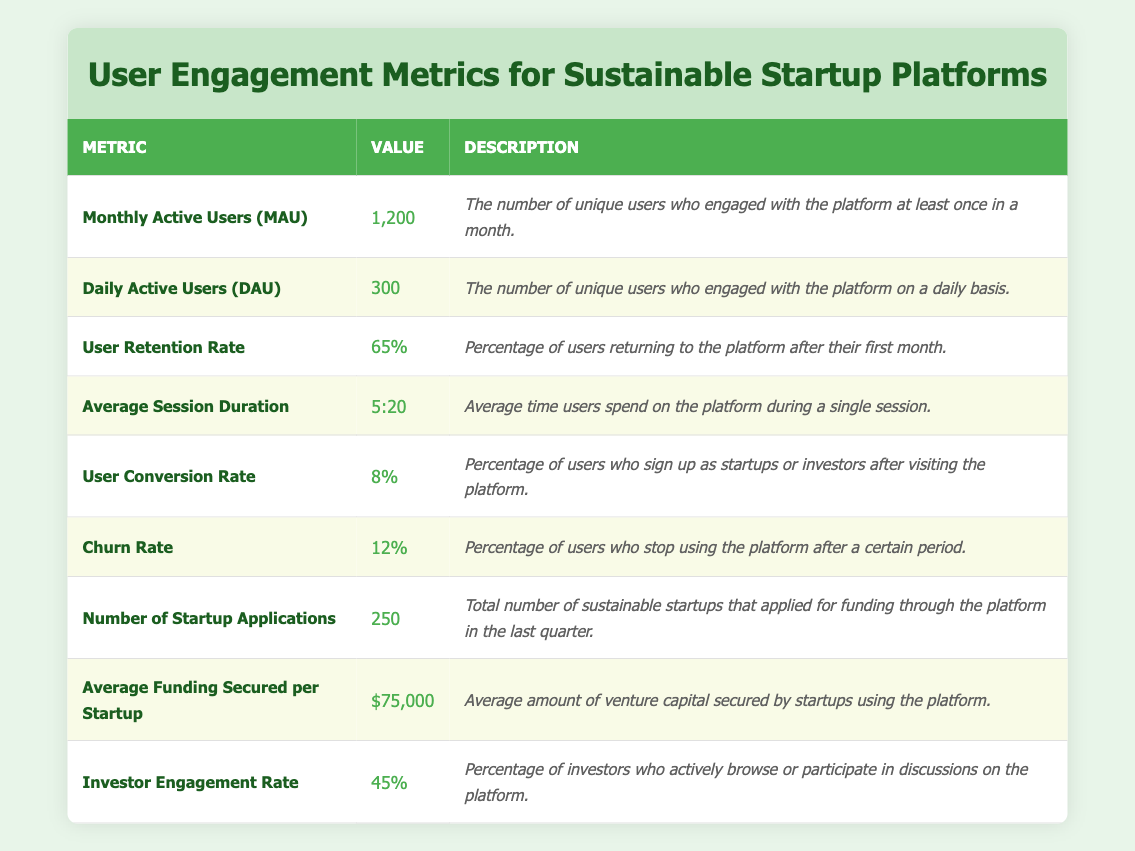What is the number of Monthly Active Users (MAU)? The table indicates that the value for Monthly Active Users (MAU) is 1,200. This is a straightforward retrieval from the table.
Answer: 1,200 What percentage of users stop using the platform according to the Churn Rate? The Churn Rate is shown in the table as 12%. This is a direct retrieval of the value from the relevant row.
Answer: 12% How many Daily Active Users (DAU) are there compared to Monthly Active Users (MAU)? The table states there are 300 Daily Active Users (DAU) and 1,200 Monthly Active Users (MAU). The ratio is 300 DAU / 1,200 MAU = 0.25 or 25%.
Answer: 25% What is the average amount of funding secured per startup? The table lists Average Funding Secured per Startup as $75,000. This figure can be directly found in the table.
Answer: $75,000 What is the User Retention Rate in percentage? According to the table, the User Retention Rate is 65%. This answer is found by directly referencing the relevant metric row in the table.
Answer: 65% How many more startup applications were there than the average funding secured per startup if the number of applications is 250? The number of startup applications is 250, and the average funding per startup is $75,000. Since these figures represent different metrics, you cannot directly subtract funding from the number of applications. Thus, this question should be addressed more thoughtfully. The context is not applicable as they are different types of metrics.
Answer: Not applicable Is the Investor Engagement Rate greater than 40%? The table provides an Investor Engagement Rate of 45%, which is indeed greater than 40%. This is a comparison of two values directly from the table.
Answer: Yes What are the total users who engaged with the platform (sum of MAU and DAU)? The Monthly Active Users (MAU) is 1,200, and the Daily Active Users (DAU) is 300. To find the total users who engaged with the platform, we can add these two figures: 1,200 + 300 = 1,500.
Answer: 1,500 What is the difference between the User Conversion Rate and the User Retention Rate? The User Conversion Rate is 8%, and the User Retention Rate is 65%. To find the difference, we subtract the conversion rate from the retention rate: 65% - 8% = 57%.
Answer: 57% 